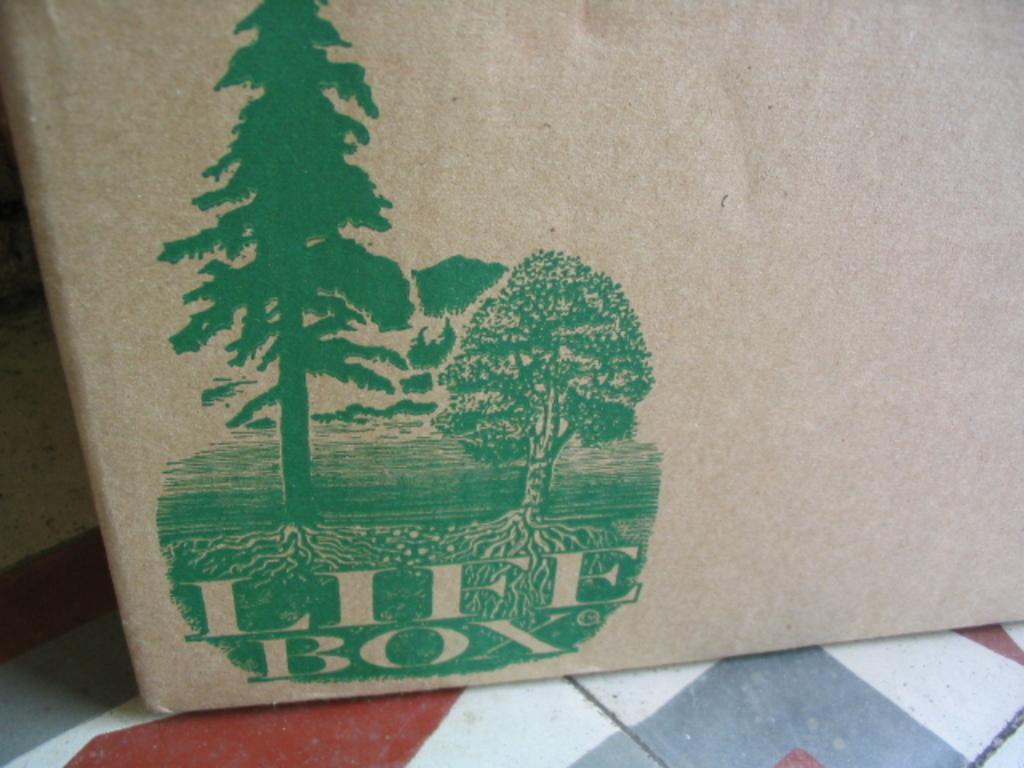<image>
Render a clear and concise summary of the photo. Brown bag showing trees and words that say Life Box. 